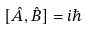<formula> <loc_0><loc_0><loc_500><loc_500>[ { \hat { A } } , { \hat { B } } ] = i \hbar</formula> 